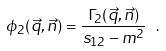<formula> <loc_0><loc_0><loc_500><loc_500>\phi _ { 2 } ( \vec { q } , \vec { n } ) = \frac { \Gamma _ { 2 } ( \vec { q } , \vec { n } ) } { s _ { 1 2 } - m ^ { 2 } } \ .</formula> 